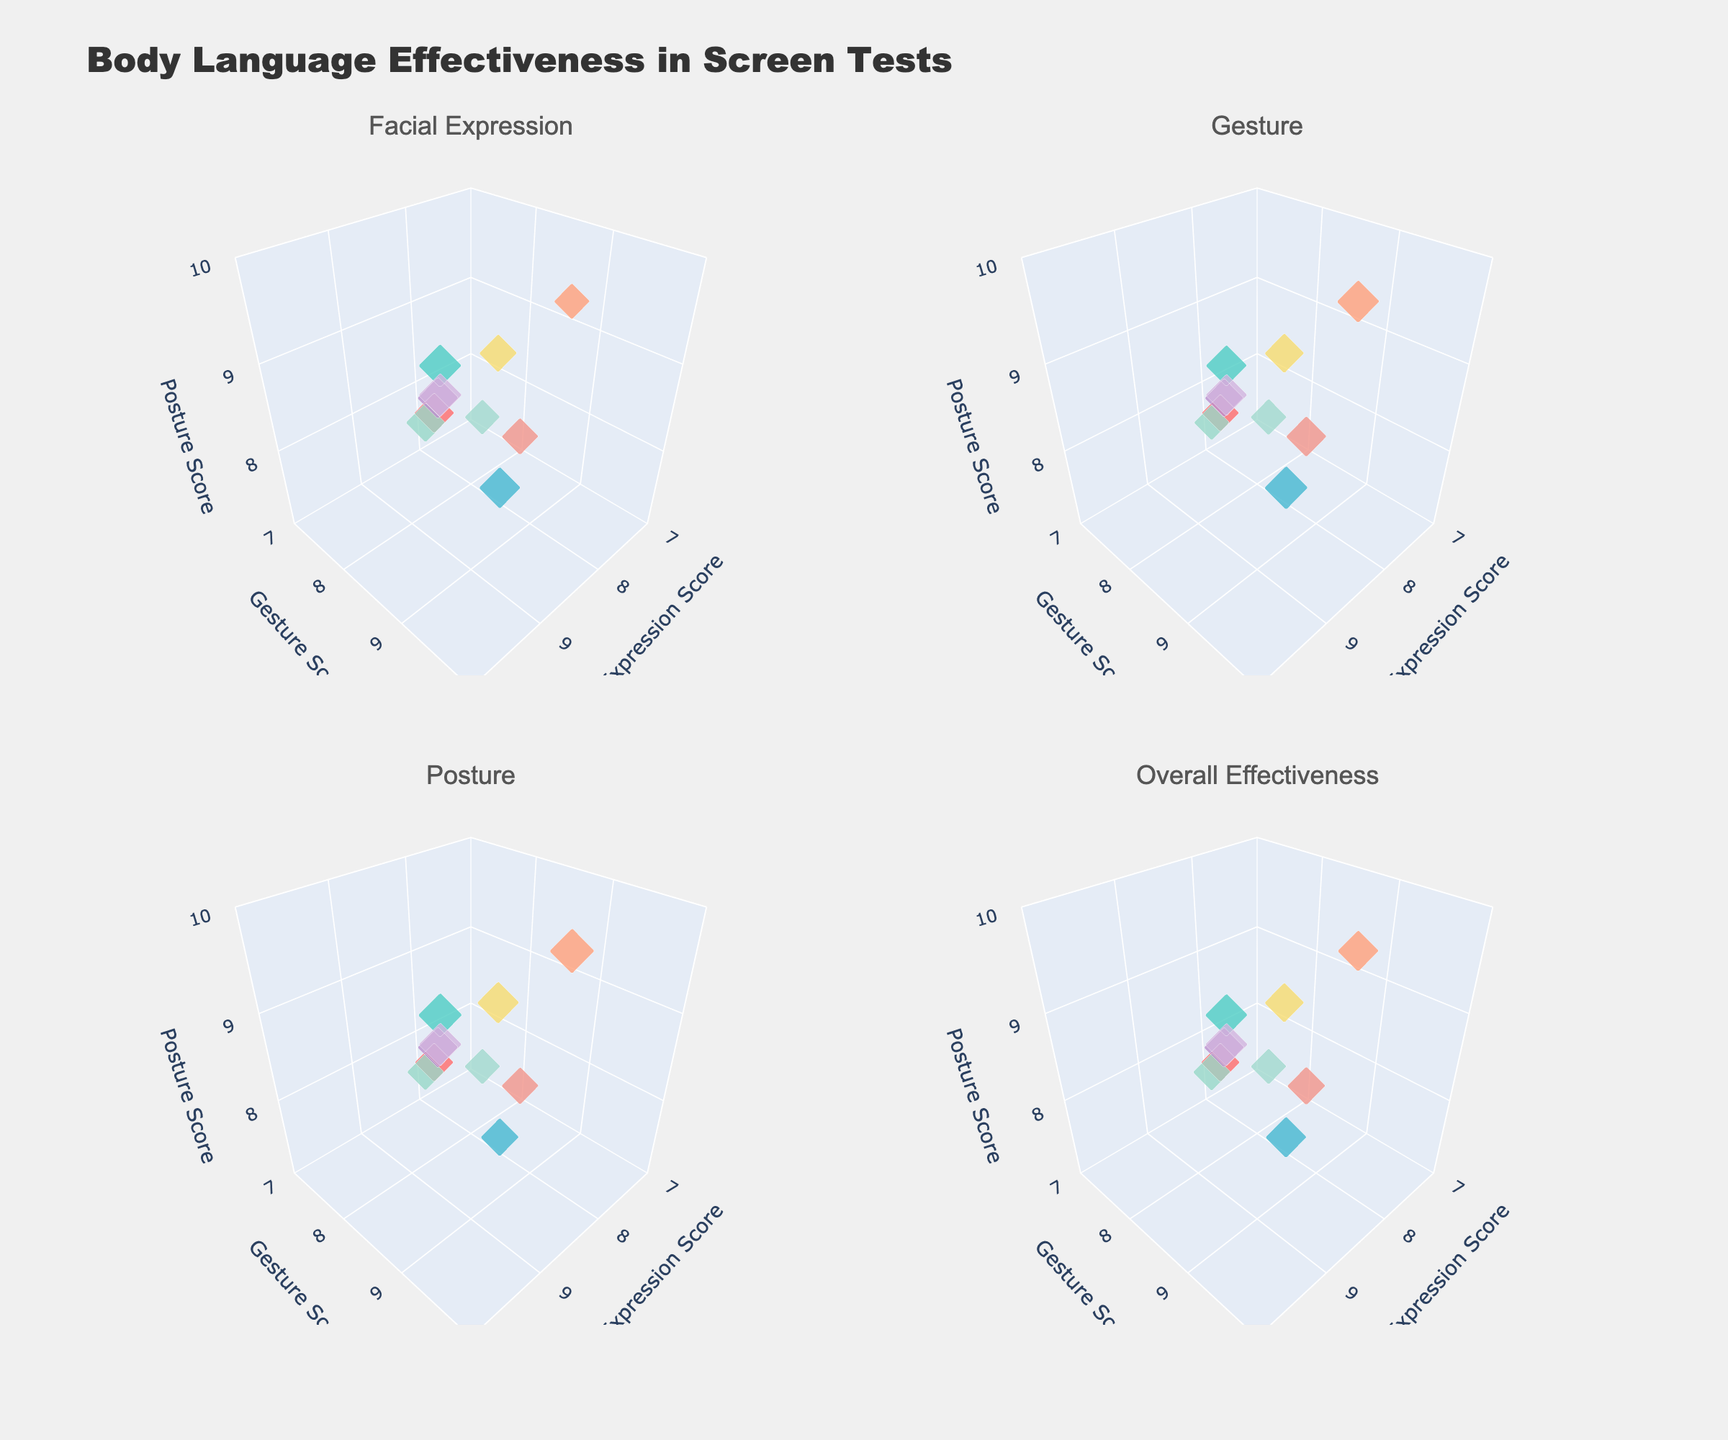What is the title of the figure? The title is located at the top center of the figure. It helps to identify the overall subject or theme of the figure.
Answer: Body Language Effectiveness in Screen Tests What character archetype has the highest Facial Expression Score? By looking at the Facial Expression Score (x-axis) on each subplot and identifying the highest value, you can see which character archetype corresponds to it.
Answer: Femme Fatale Which subplot shows the data with the largest marker sizes for the Romantic_Lead? Marker sizes in the subplots are adjusted based on the scores for Facial Expressions, Gestures, Posture, and Overall Effectiveness. Identify the subplot where the Romantic_Lead has the largest marker size.
Answer: Facial Expression How does the Gesture Score of the Comic_Relief compare to the Gesture Score of the Ingenue? Compare the position of the Comic_Relief and Ingenue on the y-axis (Gesture Score) across the subplots to see which is higher.
Answer: Comic_Relief has a higher Gesture Score What is the average Overall Effectiveness score for Action_Hero and Antihero? Look at the Overall Effectiveness subplot, identify the scores for Action_Hero and Antihero, sum them up, and divide by 2.
Answer: 8.6 Which character archetype appears to have the lowest Posture Score? Examine the Posture Score (z-axis) on each subplot to determine the character archetype with the lowest value.
Answer: Everyman Compare the Facial Expression Scores between Mentor and Sidekick. Which one is higher? On the x-axis of each subplot, locate the Facial Expression Scores for both Mentor and Sidekick and compare them.
Answer: Mentor Which character archetype has an Overall Effectiveness Score closest to 8.5? Identify the Overall Effectiveness subplot and find the data point with a score closest to 8.5.
Answer: Antihero How many character archetypes have a Gesture Score of 8 or above? Count the number of data points on the y-axis (Gesture Score) in each subplot that are 8 or higher.
Answer: 8 Is there any correlation between Facial Expression Score and Overall Effectiveness for the Villain? Check the subplot for Overall Effectiveness and compare the Villain’s position on the x-axis (Facial Expression Score) and the size of its marker.
Answer: Yes, high correlation 